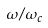<formula> <loc_0><loc_0><loc_500><loc_500>\omega / \omega _ { c }</formula> 